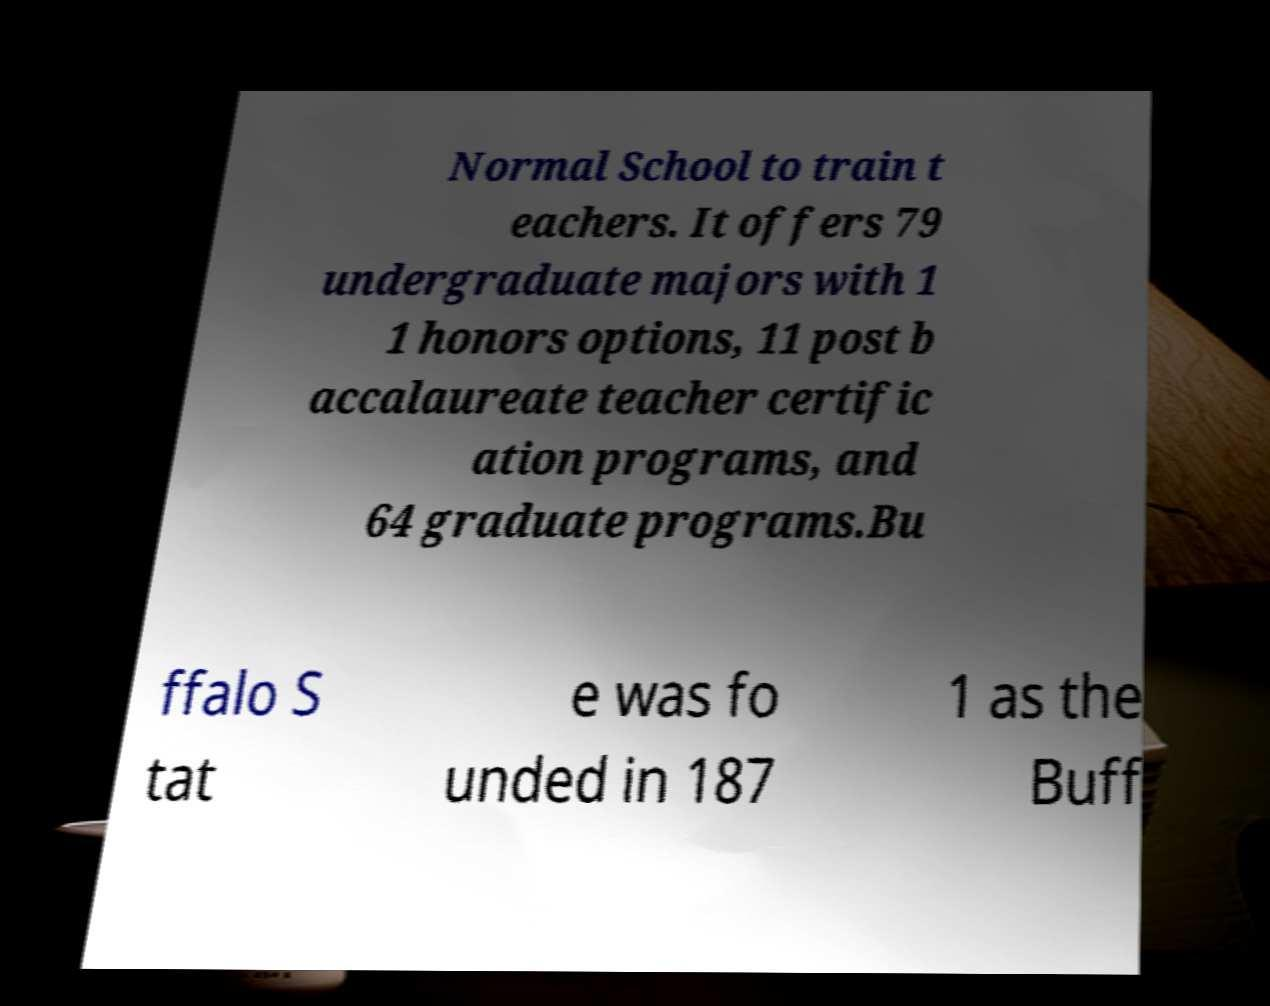Could you assist in decoding the text presented in this image and type it out clearly? Normal School to train t eachers. It offers 79 undergraduate majors with 1 1 honors options, 11 post b accalaureate teacher certific ation programs, and 64 graduate programs.Bu ffalo S tat e was fo unded in 187 1 as the Buff 